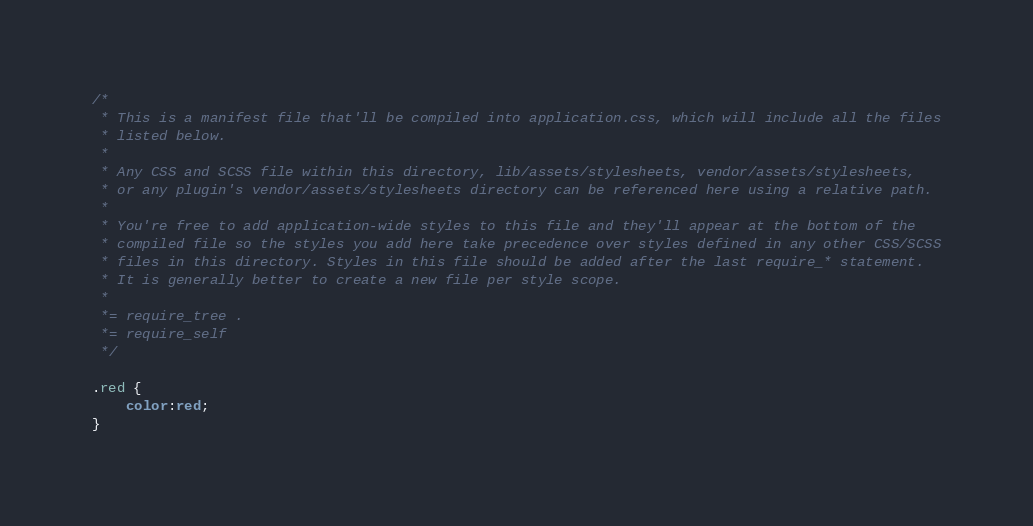Convert code to text. <code><loc_0><loc_0><loc_500><loc_500><_CSS_>/*
 * This is a manifest file that'll be compiled into application.css, which will include all the files
 * listed below.
 *
 * Any CSS and SCSS file within this directory, lib/assets/stylesheets, vendor/assets/stylesheets,
 * or any plugin's vendor/assets/stylesheets directory can be referenced here using a relative path.
 *
 * You're free to add application-wide styles to this file and they'll appear at the bottom of the
 * compiled file so the styles you add here take precedence over styles defined in any other CSS/SCSS
 * files in this directory. Styles in this file should be added after the last require_* statement.
 * It is generally better to create a new file per style scope.
 *
 *= require_tree .
 *= require_self
 */

.red {
	color:red;
}

</code> 